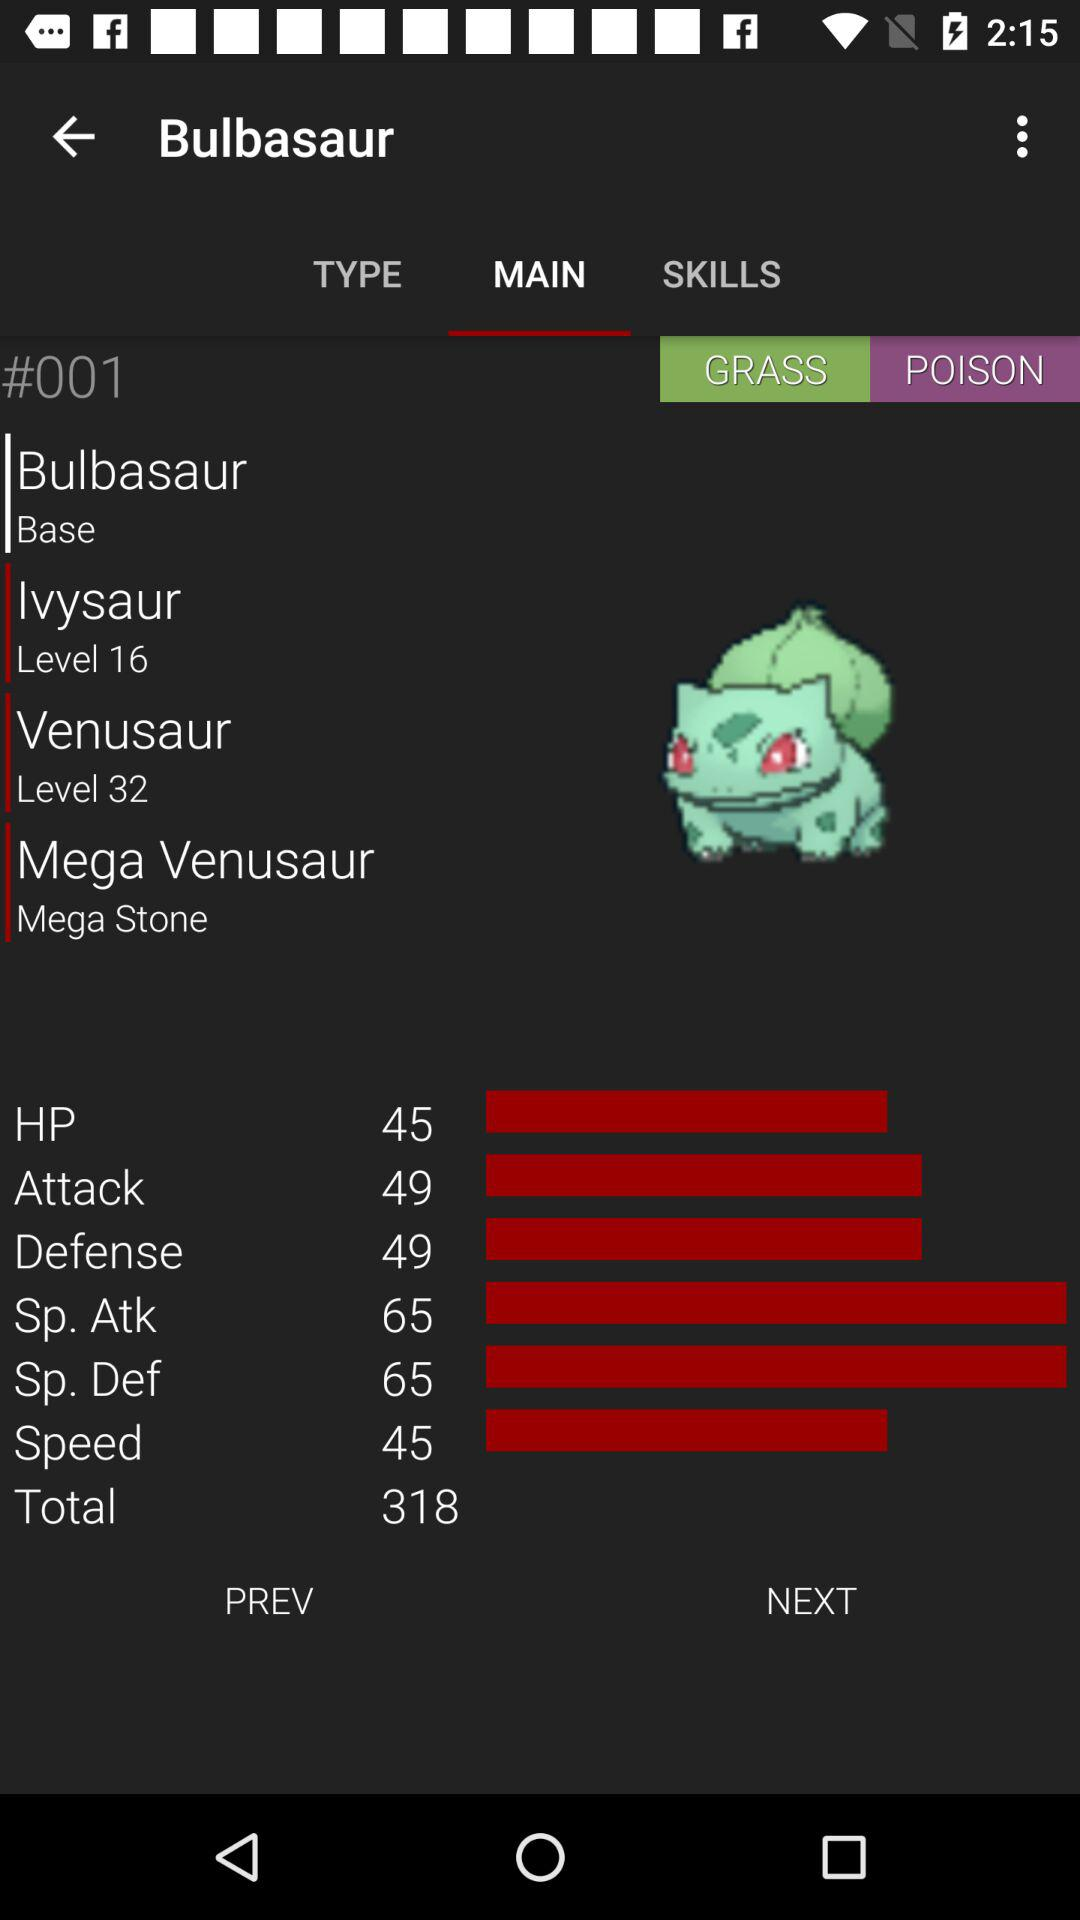What is the speed? The speed is 45. 